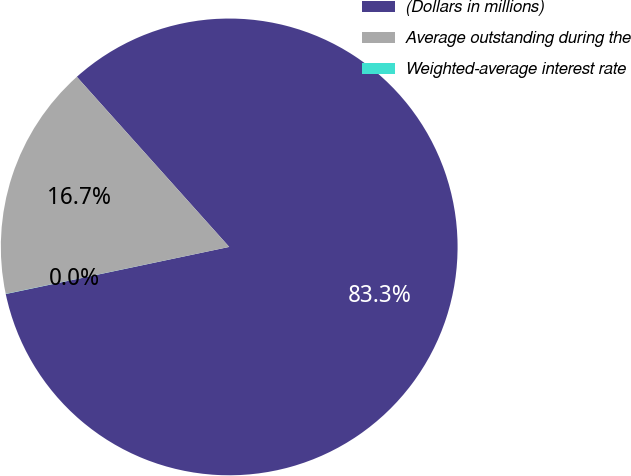<chart> <loc_0><loc_0><loc_500><loc_500><pie_chart><fcel>(Dollars in millions)<fcel>Average outstanding during the<fcel>Weighted-average interest rate<nl><fcel>83.32%<fcel>16.67%<fcel>0.01%<nl></chart> 